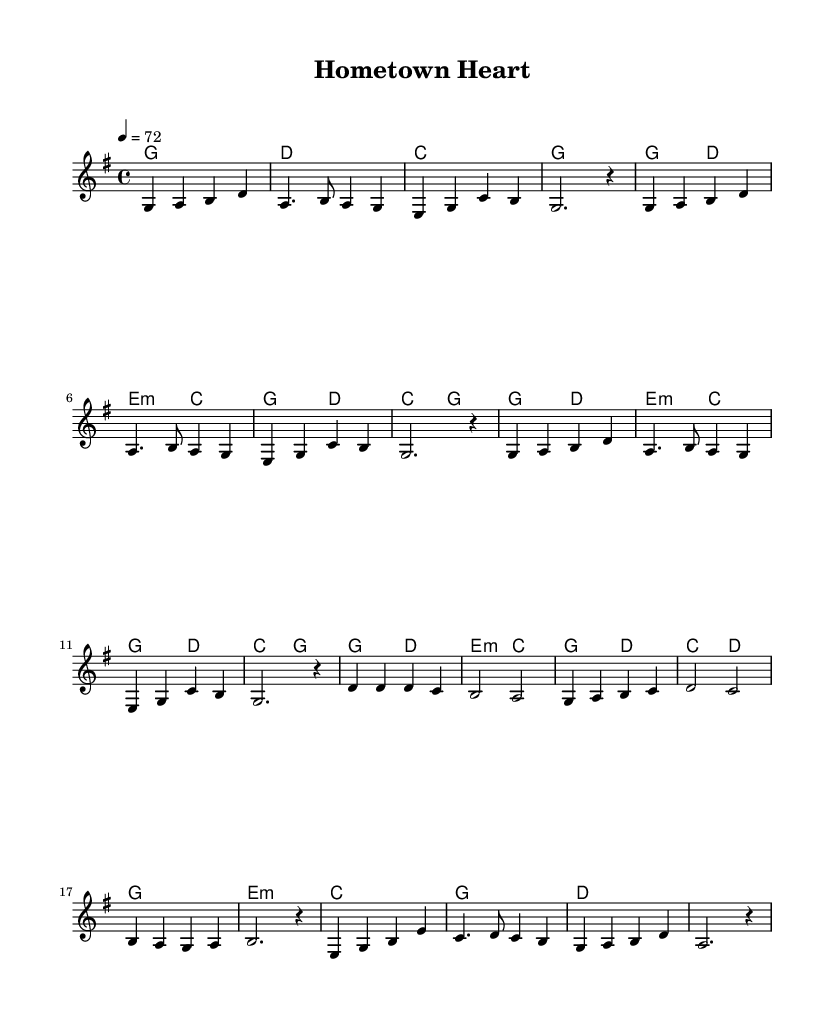What is the key signature of this music? The key signature is G major, which has one sharp (F#). This is determined by looking at the header and identifying that it specifies the key as "g".
Answer: G major What is the time signature of this music? The time signature, which is indicated at the beginning of the piece, shows that the piece is in 4/4 time, meaning there are four beats in a measure and the quarter note gets one beat.
Answer: 4/4 What is the tempo marking of this music? The tempo marking at the beginning of the score states "4 = 72", indicating that there are 72 quarter note beats per minute. Tempo refers to the speed of the music, measured in beats per minute (BPM).
Answer: 72 How many bars are in the chorus section? To find the number of bars in the chorus, we analyze the melody and the corresponding lyrics provided in the score. The chorus consists of 8 measures or bars in total.
Answer: 8 What is the primary theme of the lyrics in the verse? The lyrics in the verse focus on small-town imagery and everyday life, capturing a sense of familiarity and community. This can be inferred from keywords like "small town" and "familiar faces".
Answer: Small-town values What chords are used during the bridge section? The chords in the bridge are e minor, c major, g major, and d major, as indicated in the chord mode section. Each chord listed corresponds with the timing of the melody, concluding with a g major chord.
Answer: E minor, C, G, D How does the structure of this ballad reflect traditional country music? The structure of the piece includes verses that tell a story and a chorus that emphasizes small-town pride, which are characteristic elements of traditional country music storytelling. This thematic focus on relationships and community aligns with country music tradition.
Answer: Storytelling structure 